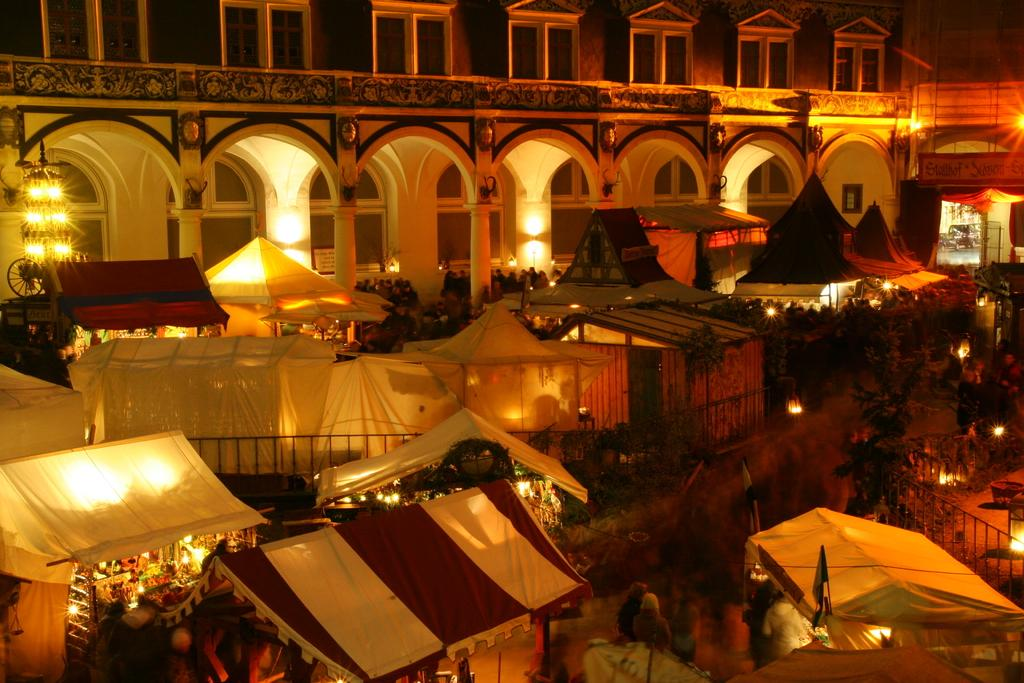What structures are on the ground in the image? There are canopy tents on the ground in the image. What can be seen illuminated in the image? There are lights visible in the image. What type of building is in the background of the image? There is an arch design building in the background of the image. What architectural features does the building have? The building has pillars and glass windows. What type of chin can be seen on the building in the image? There is no chin present on the building in the image. How many wheels are visible on the transport in the image? There is no transport visible in the image, so it is not possible to determine the number of wheels. 